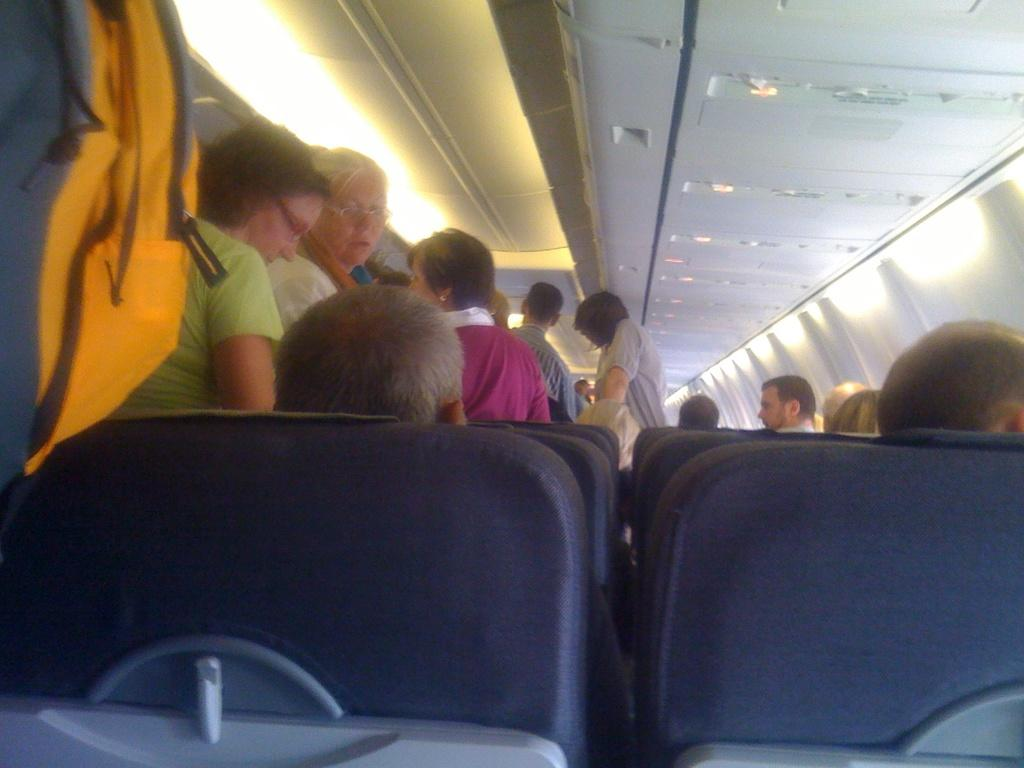What type of space is depicted in the image? The image shows the interior of a vehicle. What can be found inside the vehicle? There are seats in the vehicle, and persons are sitting and standing in the vehicle. What is visible on the ceiling of the vehicle? The ceiling of the vehicle is visible, and there are lights attached to it. Can you see a zipper on the seats in the image? There is no zipper present on the seats in the image. Is there a garden visible through the windows of the vehicle? The image does not show any windows or a garden; it only depicts the interior of the vehicle. 